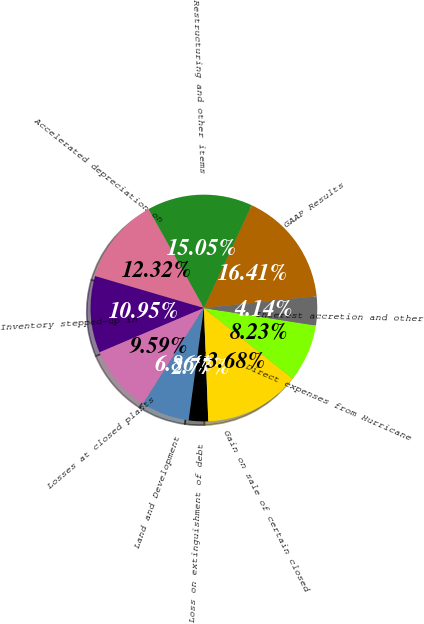Convert chart. <chart><loc_0><loc_0><loc_500><loc_500><pie_chart><fcel>GAAP Results<fcel>Restructuring and other items<fcel>Accelerated depreciation on<fcel>Inventory stepped-up in<fcel>Losses at closed plants<fcel>Land and Development<fcel>Loss on extinguishment of debt<fcel>Gain on sale of certain closed<fcel>Direct expenses from Hurricane<fcel>Interest accretion and other<nl><fcel>16.41%<fcel>15.05%<fcel>12.32%<fcel>10.95%<fcel>9.59%<fcel>6.86%<fcel>2.77%<fcel>13.68%<fcel>8.23%<fcel>4.14%<nl></chart> 